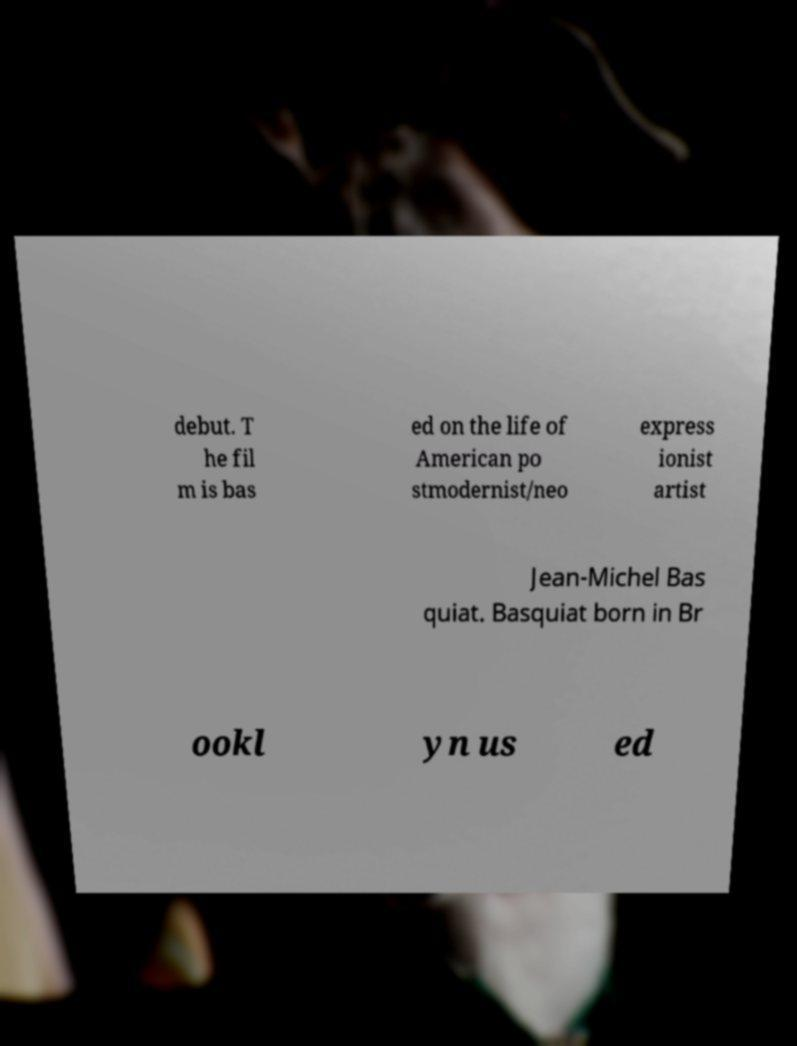There's text embedded in this image that I need extracted. Can you transcribe it verbatim? debut. T he fil m is bas ed on the life of American po stmodernist/neo express ionist artist Jean-Michel Bas quiat. Basquiat born in Br ookl yn us ed 